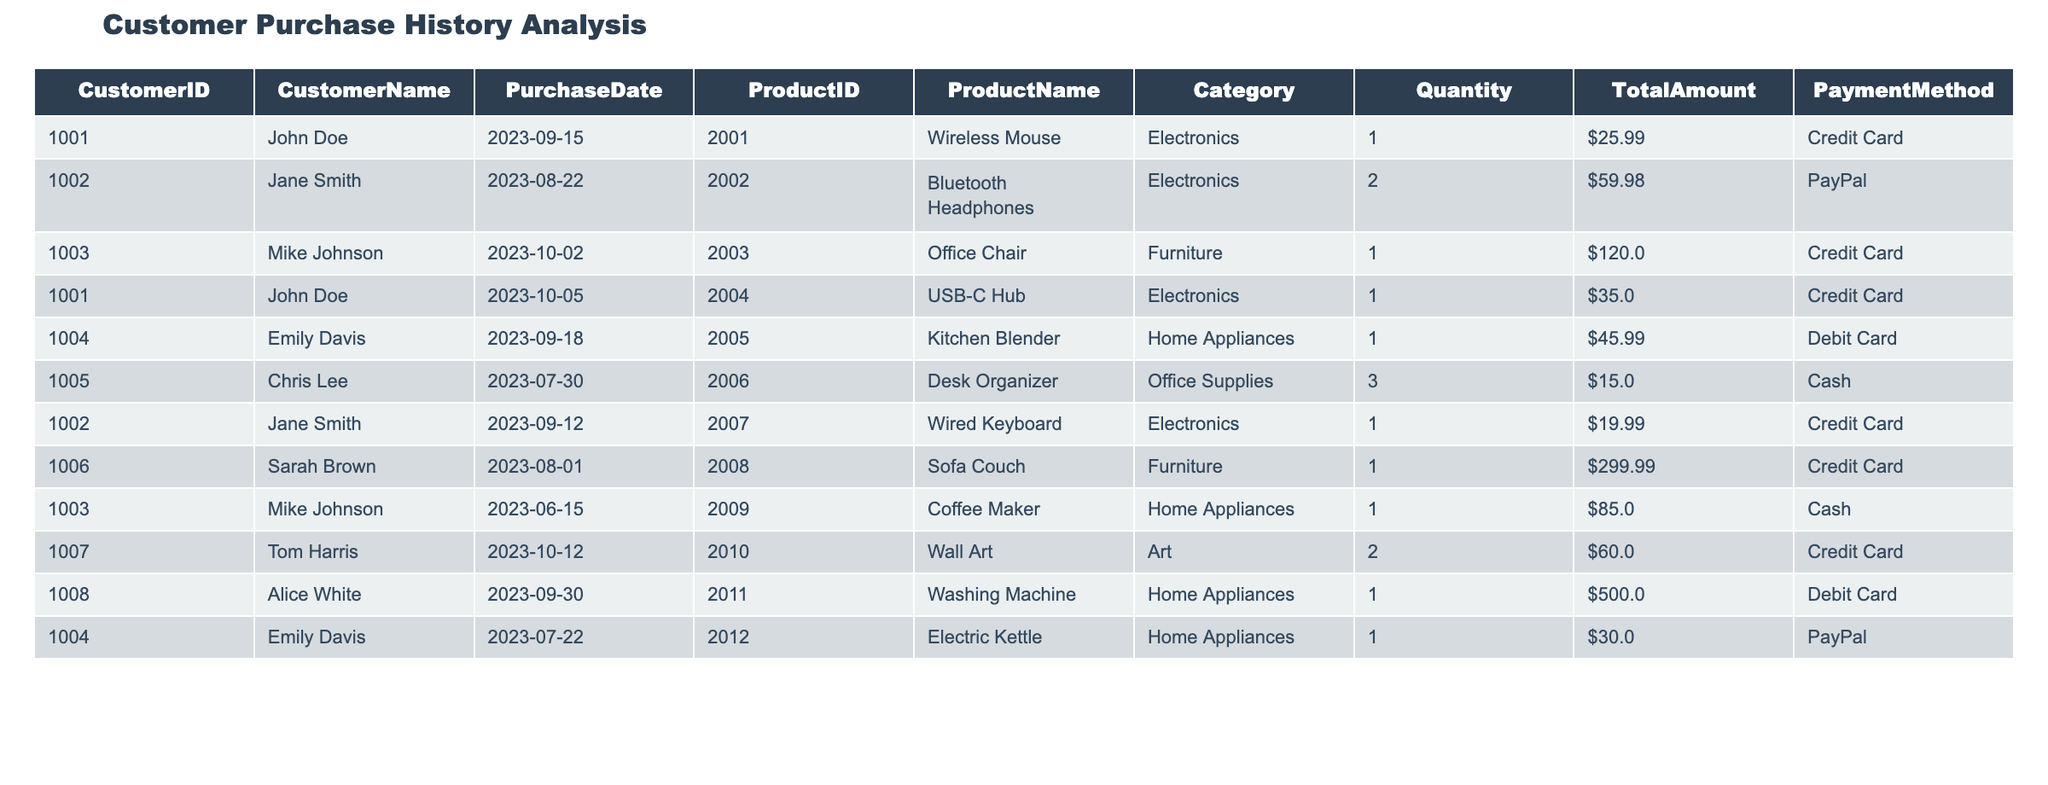What is the total number of purchases made by John Doe in the last six months? John Doe has made two purchases in the last six months: one on September 15, 2023, and another on October 5, 2023. Counting these entries gives us a total of 2.
Answer: 2 Which product had the highest total amount spent in a single transaction? The highest total amount spent in a single transaction is $500.00 for the product "Washing Machine," purchased by Alice White on September 30, 2023.
Answer: $500.00 Did Sarah Brown make any purchases using PayPal? By reviewing the table, Sarah Brown only used a Credit Card for her purchase. Therefore, she did not make any purchases using PayPal.
Answer: No What was the average quantity of products purchased by Jane Smith? Jane Smith made two purchases: 2 Bluetooth Headphones and 1 Wired Keyboard. The total quantity purchased is 2 + 1 = 3, and the average is 3 purchases divided by 2 transactions, which equals 1.5.
Answer: 1.5 Which customer spent the least total amount across all their purchases? Chris Lee spent a total of $15.00 across their single purchase of 3 Desk Organizers on July 30, 2023. No other customer has a recorded total amount that is lower than this.
Answer: $15.00 How many different payment methods were used in total for the purchases in the table? The payment methods listed are Credit Card, PayPal, Debit Card, and Cash. This makes up a total of 4 different payment methods used in the purchases.
Answer: 4 Was the total amount spent on Home Appliances greater than the total amount spent on Electronics? The total amount spent on Home Appliances is $575.99 (from Kitchen Blender, Coffee Maker, Sofa Couch, Electric Kettle, and Washing Machine), while for Electronics, it totals $105.96 (from Wireless Mouse, Bluetooth Headphones, Wired Keyboard, and USB-C Hub). Since 575.99 is greater than 105.96, the statement is true.
Answer: Yes How many purchases were made in October 2023? The data shows three purchases made in October 2023: one by Mike Johnson on October 2, one by John Doe on October 5, and one by Tom Harris on October 12. Therefore, the total number of purchases in October is 3.
Answer: 3 